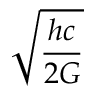<formula> <loc_0><loc_0><loc_500><loc_500>\sqrt { \frac { h c } { 2 G } }</formula> 